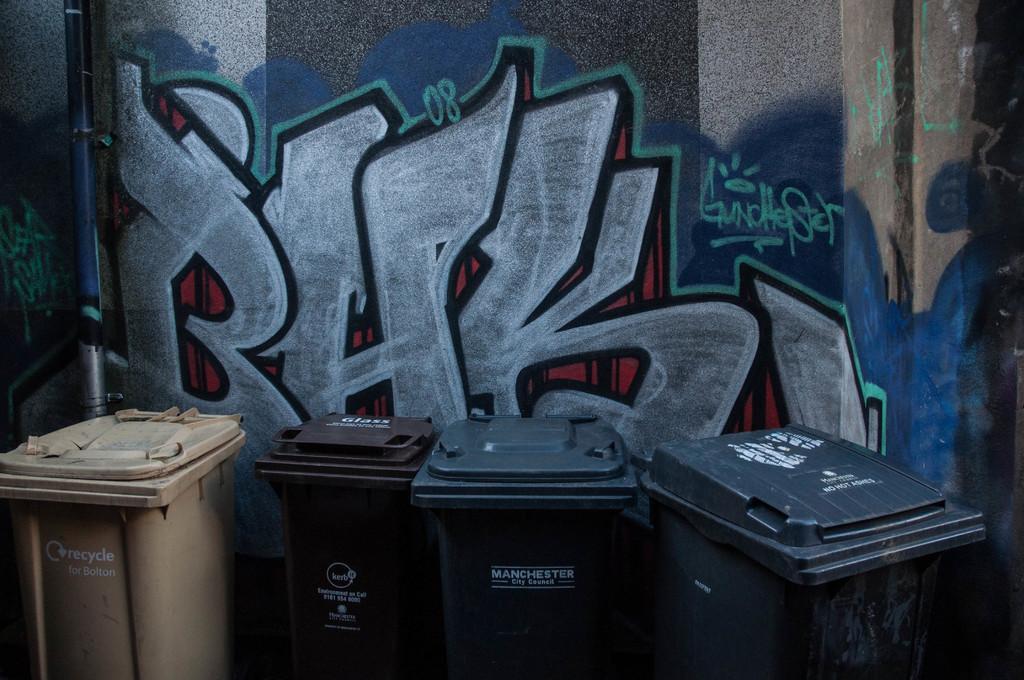Please provide a concise description of this image. In the picture I can see four garbage bins and in the background, I can see the wall on which I can see the graffiti art. 